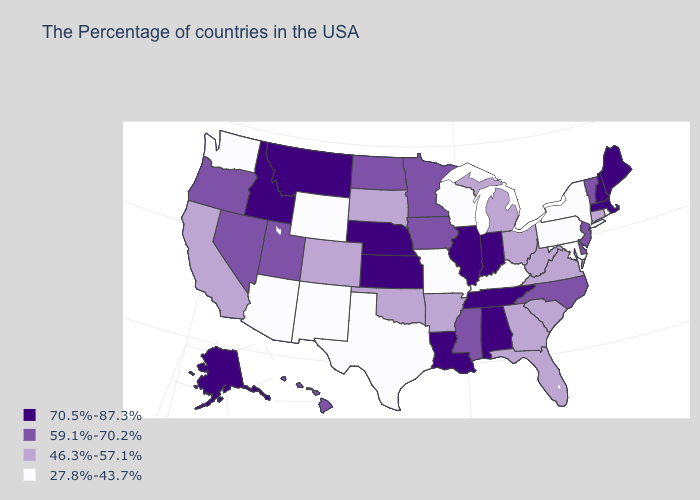How many symbols are there in the legend?
Concise answer only. 4. How many symbols are there in the legend?
Be succinct. 4. Which states have the lowest value in the USA?
Write a very short answer. Rhode Island, New York, Maryland, Pennsylvania, Kentucky, Wisconsin, Missouri, Texas, Wyoming, New Mexico, Arizona, Washington. What is the lowest value in the USA?
Write a very short answer. 27.8%-43.7%. Name the states that have a value in the range 59.1%-70.2%?
Short answer required. Vermont, New Jersey, Delaware, North Carolina, Mississippi, Minnesota, Iowa, North Dakota, Utah, Nevada, Oregon, Hawaii. What is the value of Massachusetts?
Concise answer only. 70.5%-87.3%. What is the value of New Mexico?
Concise answer only. 27.8%-43.7%. What is the value of Arizona?
Answer briefly. 27.8%-43.7%. Name the states that have a value in the range 70.5%-87.3%?
Short answer required. Maine, Massachusetts, New Hampshire, Indiana, Alabama, Tennessee, Illinois, Louisiana, Kansas, Nebraska, Montana, Idaho, Alaska. Among the states that border Massachusetts , does Connecticut have the lowest value?
Quick response, please. No. What is the value of West Virginia?
Short answer required. 46.3%-57.1%. How many symbols are there in the legend?
Write a very short answer. 4. Does Pennsylvania have the same value as Mississippi?
Keep it brief. No. Name the states that have a value in the range 70.5%-87.3%?
Write a very short answer. Maine, Massachusetts, New Hampshire, Indiana, Alabama, Tennessee, Illinois, Louisiana, Kansas, Nebraska, Montana, Idaho, Alaska. Name the states that have a value in the range 46.3%-57.1%?
Quick response, please. Connecticut, Virginia, South Carolina, West Virginia, Ohio, Florida, Georgia, Michigan, Arkansas, Oklahoma, South Dakota, Colorado, California. 